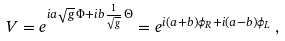Convert formula to latex. <formula><loc_0><loc_0><loc_500><loc_500>V = e ^ { i a \sqrt { g } \, \Phi + i b \frac { 1 } { \sqrt { g } } \, \Theta } = e ^ { i ( a + b ) \phi _ { R } + i ( a - b ) \phi _ { L } } \, ,</formula> 